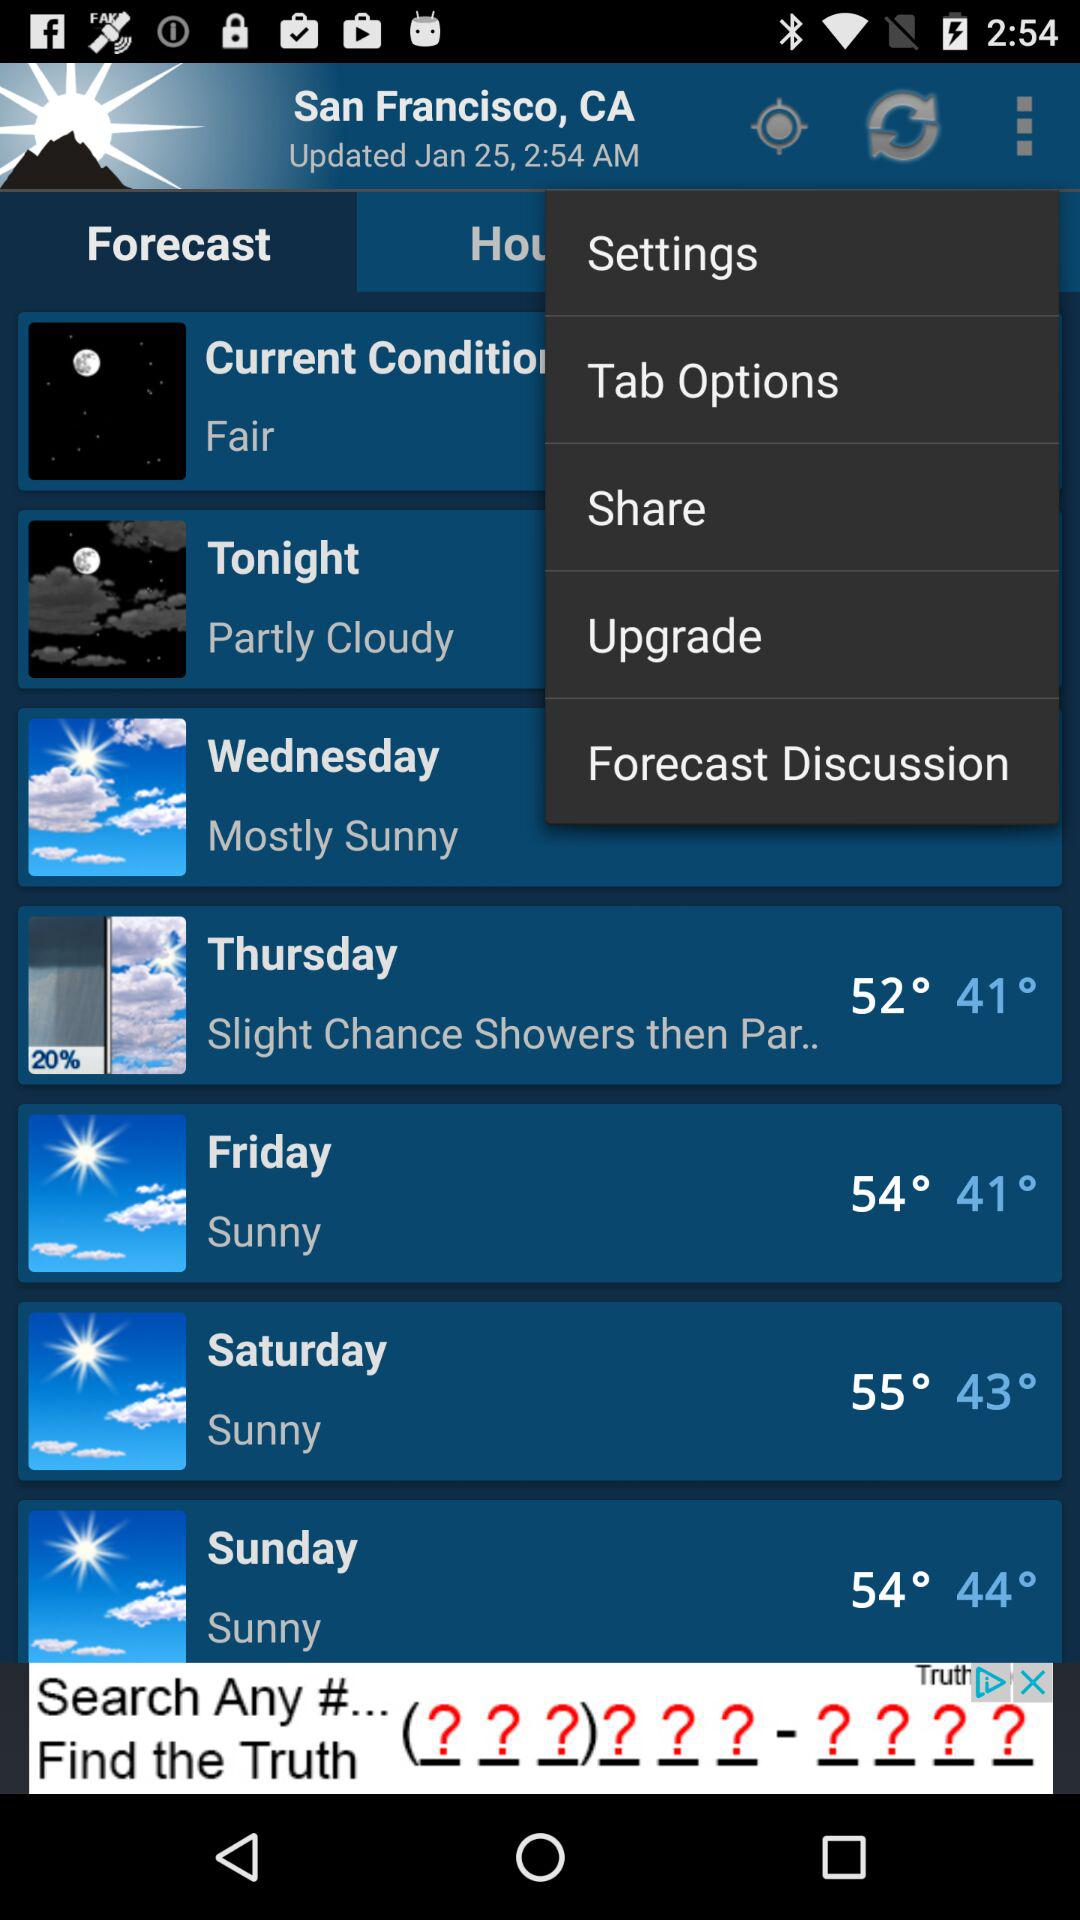How many degrees Fahrenheit is the difference between the high temperature on Thursday and the high temperature on Friday?
Answer the question using a single word or phrase. 2 